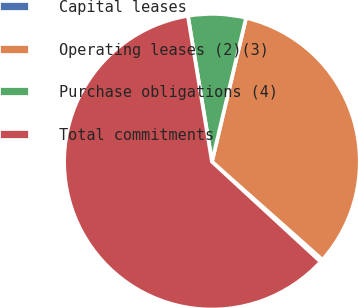Convert chart. <chart><loc_0><loc_0><loc_500><loc_500><pie_chart><fcel>Capital leases<fcel>Operating leases (2)(3)<fcel>Purchase obligations (4)<fcel>Total commitments<nl><fcel>0.29%<fcel>32.85%<fcel>6.31%<fcel>60.55%<nl></chart> 